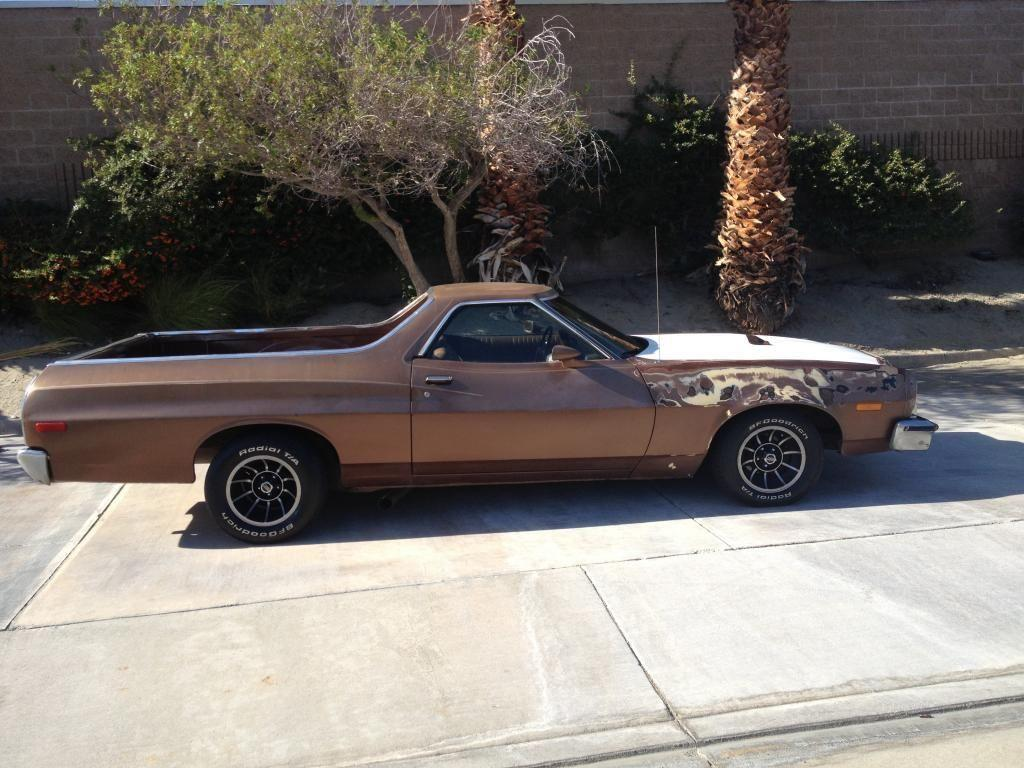What is the main subject of the image? There is a vehicle in the image. Can you describe the color of the vehicle? The vehicle is brown in color. What can be seen in the background of the image? There are trees in the background of the image. What is the color of the trees? The trees are green in color. What else is visible in the image? There is a wall visible in the image. How many cattle are grazing near the vehicle in the image? There are no cattle present in the image. What type of pies are being sold at the nearby bakery in the image? There is no bakery or pies mentioned in the image. 